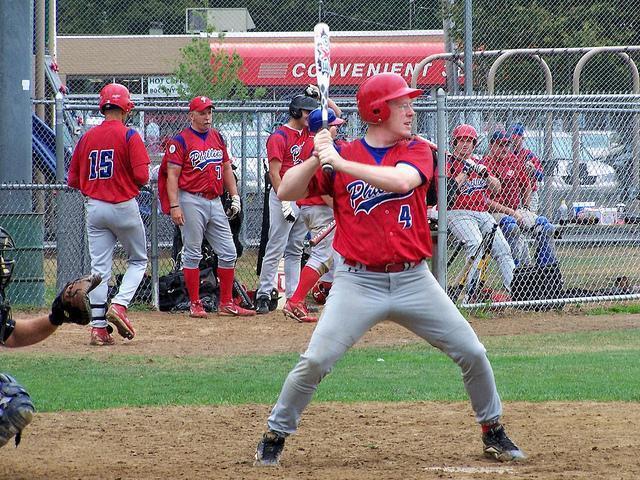How many people are holding bats?
Give a very brief answer. 2. How many people can you see?
Give a very brief answer. 8. How many cars can be seen?
Give a very brief answer. 2. How many trucks are there?
Give a very brief answer. 0. 